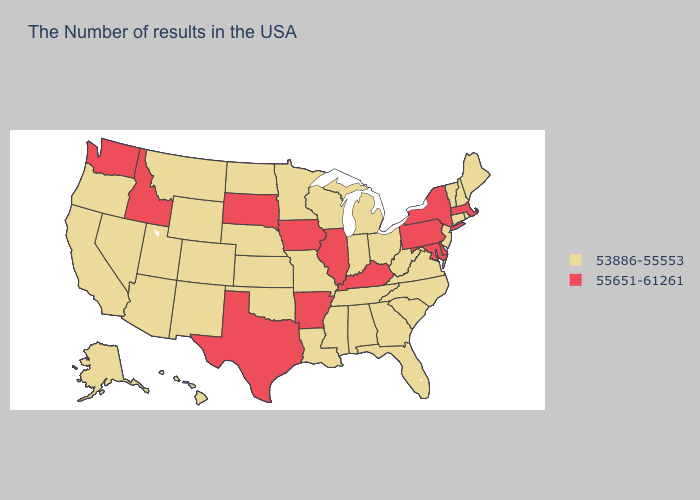What is the lowest value in states that border Michigan?
Quick response, please. 53886-55553. Which states have the lowest value in the USA?
Answer briefly. Maine, Rhode Island, New Hampshire, Vermont, Connecticut, New Jersey, Virginia, North Carolina, South Carolina, West Virginia, Ohio, Florida, Georgia, Michigan, Indiana, Alabama, Tennessee, Wisconsin, Mississippi, Louisiana, Missouri, Minnesota, Kansas, Nebraska, Oklahoma, North Dakota, Wyoming, Colorado, New Mexico, Utah, Montana, Arizona, Nevada, California, Oregon, Alaska, Hawaii. What is the value of Indiana?
Concise answer only. 53886-55553. Name the states that have a value in the range 53886-55553?
Quick response, please. Maine, Rhode Island, New Hampshire, Vermont, Connecticut, New Jersey, Virginia, North Carolina, South Carolina, West Virginia, Ohio, Florida, Georgia, Michigan, Indiana, Alabama, Tennessee, Wisconsin, Mississippi, Louisiana, Missouri, Minnesota, Kansas, Nebraska, Oklahoma, North Dakota, Wyoming, Colorado, New Mexico, Utah, Montana, Arizona, Nevada, California, Oregon, Alaska, Hawaii. Name the states that have a value in the range 53886-55553?
Quick response, please. Maine, Rhode Island, New Hampshire, Vermont, Connecticut, New Jersey, Virginia, North Carolina, South Carolina, West Virginia, Ohio, Florida, Georgia, Michigan, Indiana, Alabama, Tennessee, Wisconsin, Mississippi, Louisiana, Missouri, Minnesota, Kansas, Nebraska, Oklahoma, North Dakota, Wyoming, Colorado, New Mexico, Utah, Montana, Arizona, Nevada, California, Oregon, Alaska, Hawaii. Does Idaho have the highest value in the West?
Keep it brief. Yes. Does Michigan have the highest value in the MidWest?
Concise answer only. No. Name the states that have a value in the range 55651-61261?
Give a very brief answer. Massachusetts, New York, Delaware, Maryland, Pennsylvania, Kentucky, Illinois, Arkansas, Iowa, Texas, South Dakota, Idaho, Washington. Which states hav the highest value in the South?
Keep it brief. Delaware, Maryland, Kentucky, Arkansas, Texas. Does Louisiana have a lower value than Ohio?
Write a very short answer. No. Among the states that border Arkansas , which have the lowest value?
Quick response, please. Tennessee, Mississippi, Louisiana, Missouri, Oklahoma. Does Massachusetts have the highest value in the Northeast?
Answer briefly. Yes. What is the lowest value in the Northeast?
Write a very short answer. 53886-55553. Which states have the lowest value in the MidWest?
Quick response, please. Ohio, Michigan, Indiana, Wisconsin, Missouri, Minnesota, Kansas, Nebraska, North Dakota. Name the states that have a value in the range 55651-61261?
Give a very brief answer. Massachusetts, New York, Delaware, Maryland, Pennsylvania, Kentucky, Illinois, Arkansas, Iowa, Texas, South Dakota, Idaho, Washington. 